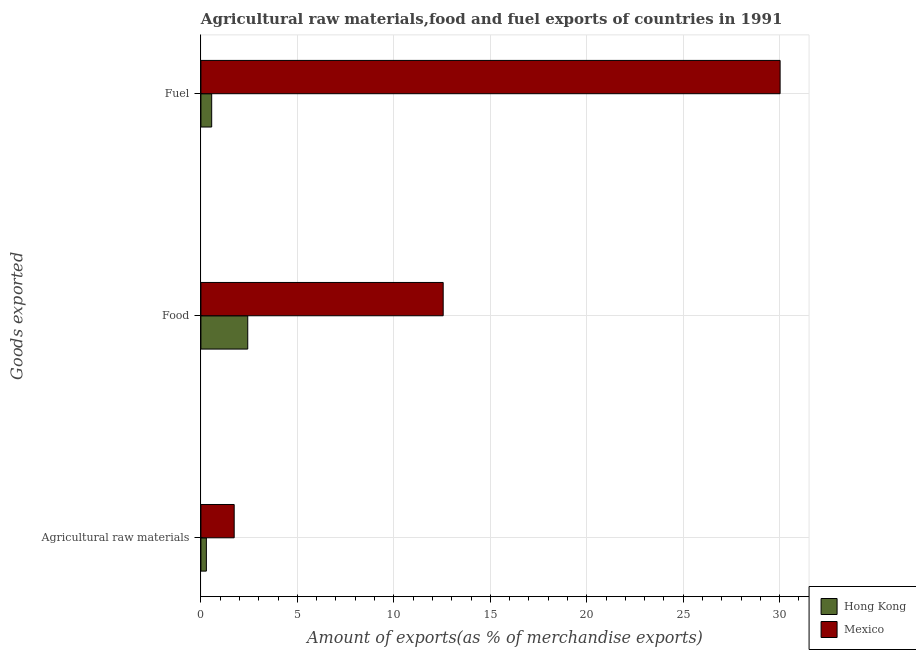How many groups of bars are there?
Ensure brevity in your answer.  3. Are the number of bars per tick equal to the number of legend labels?
Provide a short and direct response. Yes. Are the number of bars on each tick of the Y-axis equal?
Provide a short and direct response. Yes. What is the label of the 1st group of bars from the top?
Make the answer very short. Fuel. What is the percentage of raw materials exports in Mexico?
Your answer should be compact. 1.72. Across all countries, what is the maximum percentage of raw materials exports?
Give a very brief answer. 1.72. Across all countries, what is the minimum percentage of raw materials exports?
Your response must be concise. 0.28. In which country was the percentage of food exports minimum?
Give a very brief answer. Hong Kong. What is the total percentage of raw materials exports in the graph?
Ensure brevity in your answer.  2.01. What is the difference between the percentage of fuel exports in Mexico and that in Hong Kong?
Provide a succinct answer. 29.46. What is the difference between the percentage of raw materials exports in Hong Kong and the percentage of fuel exports in Mexico?
Ensure brevity in your answer.  -29.74. What is the average percentage of raw materials exports per country?
Keep it short and to the point. 1. What is the difference between the percentage of raw materials exports and percentage of fuel exports in Mexico?
Offer a terse response. -28.3. What is the ratio of the percentage of raw materials exports in Mexico to that in Hong Kong?
Offer a very short reply. 6.1. Is the difference between the percentage of raw materials exports in Hong Kong and Mexico greater than the difference between the percentage of fuel exports in Hong Kong and Mexico?
Your response must be concise. Yes. What is the difference between the highest and the second highest percentage of raw materials exports?
Give a very brief answer. 1.44. What is the difference between the highest and the lowest percentage of fuel exports?
Give a very brief answer. 29.46. In how many countries, is the percentage of food exports greater than the average percentage of food exports taken over all countries?
Provide a short and direct response. 1. Is the sum of the percentage of raw materials exports in Mexico and Hong Kong greater than the maximum percentage of food exports across all countries?
Your answer should be compact. No. Is it the case that in every country, the sum of the percentage of raw materials exports and percentage of food exports is greater than the percentage of fuel exports?
Your answer should be very brief. No. How many countries are there in the graph?
Offer a very short reply. 2. Does the graph contain grids?
Offer a terse response. Yes. How many legend labels are there?
Your answer should be compact. 2. What is the title of the graph?
Provide a succinct answer. Agricultural raw materials,food and fuel exports of countries in 1991. Does "Bhutan" appear as one of the legend labels in the graph?
Provide a succinct answer. No. What is the label or title of the X-axis?
Keep it short and to the point. Amount of exports(as % of merchandise exports). What is the label or title of the Y-axis?
Ensure brevity in your answer.  Goods exported. What is the Amount of exports(as % of merchandise exports) of Hong Kong in Agricultural raw materials?
Your response must be concise. 0.28. What is the Amount of exports(as % of merchandise exports) in Mexico in Agricultural raw materials?
Give a very brief answer. 1.72. What is the Amount of exports(as % of merchandise exports) of Hong Kong in Food?
Give a very brief answer. 2.43. What is the Amount of exports(as % of merchandise exports) of Mexico in Food?
Offer a terse response. 12.56. What is the Amount of exports(as % of merchandise exports) of Hong Kong in Fuel?
Your answer should be compact. 0.56. What is the Amount of exports(as % of merchandise exports) of Mexico in Fuel?
Offer a terse response. 30.02. Across all Goods exported, what is the maximum Amount of exports(as % of merchandise exports) of Hong Kong?
Offer a very short reply. 2.43. Across all Goods exported, what is the maximum Amount of exports(as % of merchandise exports) in Mexico?
Make the answer very short. 30.02. Across all Goods exported, what is the minimum Amount of exports(as % of merchandise exports) of Hong Kong?
Provide a succinct answer. 0.28. Across all Goods exported, what is the minimum Amount of exports(as % of merchandise exports) of Mexico?
Give a very brief answer. 1.72. What is the total Amount of exports(as % of merchandise exports) in Hong Kong in the graph?
Make the answer very short. 3.27. What is the total Amount of exports(as % of merchandise exports) in Mexico in the graph?
Give a very brief answer. 44.3. What is the difference between the Amount of exports(as % of merchandise exports) of Hong Kong in Agricultural raw materials and that in Food?
Your answer should be compact. -2.14. What is the difference between the Amount of exports(as % of merchandise exports) in Mexico in Agricultural raw materials and that in Food?
Your answer should be compact. -10.83. What is the difference between the Amount of exports(as % of merchandise exports) of Hong Kong in Agricultural raw materials and that in Fuel?
Offer a very short reply. -0.28. What is the difference between the Amount of exports(as % of merchandise exports) in Mexico in Agricultural raw materials and that in Fuel?
Give a very brief answer. -28.3. What is the difference between the Amount of exports(as % of merchandise exports) in Hong Kong in Food and that in Fuel?
Provide a short and direct response. 1.87. What is the difference between the Amount of exports(as % of merchandise exports) of Mexico in Food and that in Fuel?
Offer a terse response. -17.46. What is the difference between the Amount of exports(as % of merchandise exports) of Hong Kong in Agricultural raw materials and the Amount of exports(as % of merchandise exports) of Mexico in Food?
Make the answer very short. -12.28. What is the difference between the Amount of exports(as % of merchandise exports) in Hong Kong in Agricultural raw materials and the Amount of exports(as % of merchandise exports) in Mexico in Fuel?
Offer a terse response. -29.74. What is the difference between the Amount of exports(as % of merchandise exports) of Hong Kong in Food and the Amount of exports(as % of merchandise exports) of Mexico in Fuel?
Provide a short and direct response. -27.59. What is the average Amount of exports(as % of merchandise exports) in Hong Kong per Goods exported?
Give a very brief answer. 1.09. What is the average Amount of exports(as % of merchandise exports) of Mexico per Goods exported?
Ensure brevity in your answer.  14.77. What is the difference between the Amount of exports(as % of merchandise exports) of Hong Kong and Amount of exports(as % of merchandise exports) of Mexico in Agricultural raw materials?
Your response must be concise. -1.44. What is the difference between the Amount of exports(as % of merchandise exports) in Hong Kong and Amount of exports(as % of merchandise exports) in Mexico in Food?
Your response must be concise. -10.13. What is the difference between the Amount of exports(as % of merchandise exports) in Hong Kong and Amount of exports(as % of merchandise exports) in Mexico in Fuel?
Provide a succinct answer. -29.46. What is the ratio of the Amount of exports(as % of merchandise exports) in Hong Kong in Agricultural raw materials to that in Food?
Ensure brevity in your answer.  0.12. What is the ratio of the Amount of exports(as % of merchandise exports) in Mexico in Agricultural raw materials to that in Food?
Keep it short and to the point. 0.14. What is the ratio of the Amount of exports(as % of merchandise exports) in Hong Kong in Agricultural raw materials to that in Fuel?
Give a very brief answer. 0.51. What is the ratio of the Amount of exports(as % of merchandise exports) of Mexico in Agricultural raw materials to that in Fuel?
Give a very brief answer. 0.06. What is the ratio of the Amount of exports(as % of merchandise exports) in Hong Kong in Food to that in Fuel?
Give a very brief answer. 4.35. What is the ratio of the Amount of exports(as % of merchandise exports) of Mexico in Food to that in Fuel?
Your response must be concise. 0.42. What is the difference between the highest and the second highest Amount of exports(as % of merchandise exports) of Hong Kong?
Give a very brief answer. 1.87. What is the difference between the highest and the second highest Amount of exports(as % of merchandise exports) in Mexico?
Provide a short and direct response. 17.46. What is the difference between the highest and the lowest Amount of exports(as % of merchandise exports) of Hong Kong?
Provide a short and direct response. 2.14. What is the difference between the highest and the lowest Amount of exports(as % of merchandise exports) of Mexico?
Offer a very short reply. 28.3. 